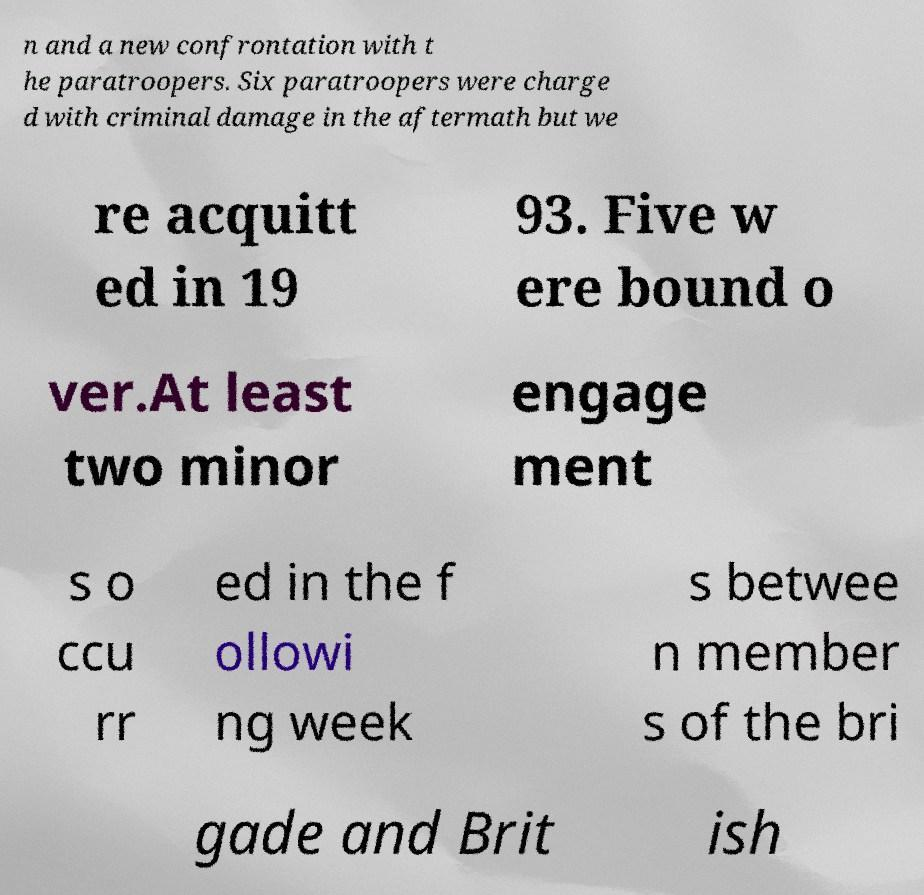For documentation purposes, I need the text within this image transcribed. Could you provide that? n and a new confrontation with t he paratroopers. Six paratroopers were charge d with criminal damage in the aftermath but we re acquitt ed in 19 93. Five w ere bound o ver.At least two minor engage ment s o ccu rr ed in the f ollowi ng week s betwee n member s of the bri gade and Brit ish 